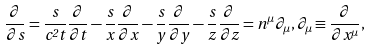Convert formula to latex. <formula><loc_0><loc_0><loc_500><loc_500>\frac { \partial } { \partial s } = \frac { s } { c ^ { 2 } t } \frac { \partial } { \partial t } - \frac { s } { x } \frac { \partial } { \partial x } - \frac { s } { y } \frac { \partial } { \partial y } - \frac { s } { z } \frac { \partial } { \partial z } = { n } ^ { \mu } \partial _ { \mu } , \partial _ { \mu } \equiv \frac { \partial } { \partial x ^ { \mu } } ,</formula> 